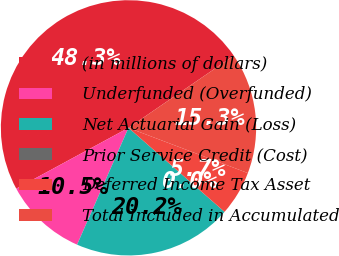Convert chart. <chart><loc_0><loc_0><loc_500><loc_500><pie_chart><fcel>(in millions of dollars)<fcel>Underfunded (Overfunded)<fcel>Net Actuarial Gain (Loss)<fcel>Prior Service Credit (Cost)<fcel>Deferred Income Tax Asset<fcel>Total Included in Accumulated<nl><fcel>48.34%<fcel>10.5%<fcel>20.16%<fcel>0.0%<fcel>5.67%<fcel>15.33%<nl></chart> 